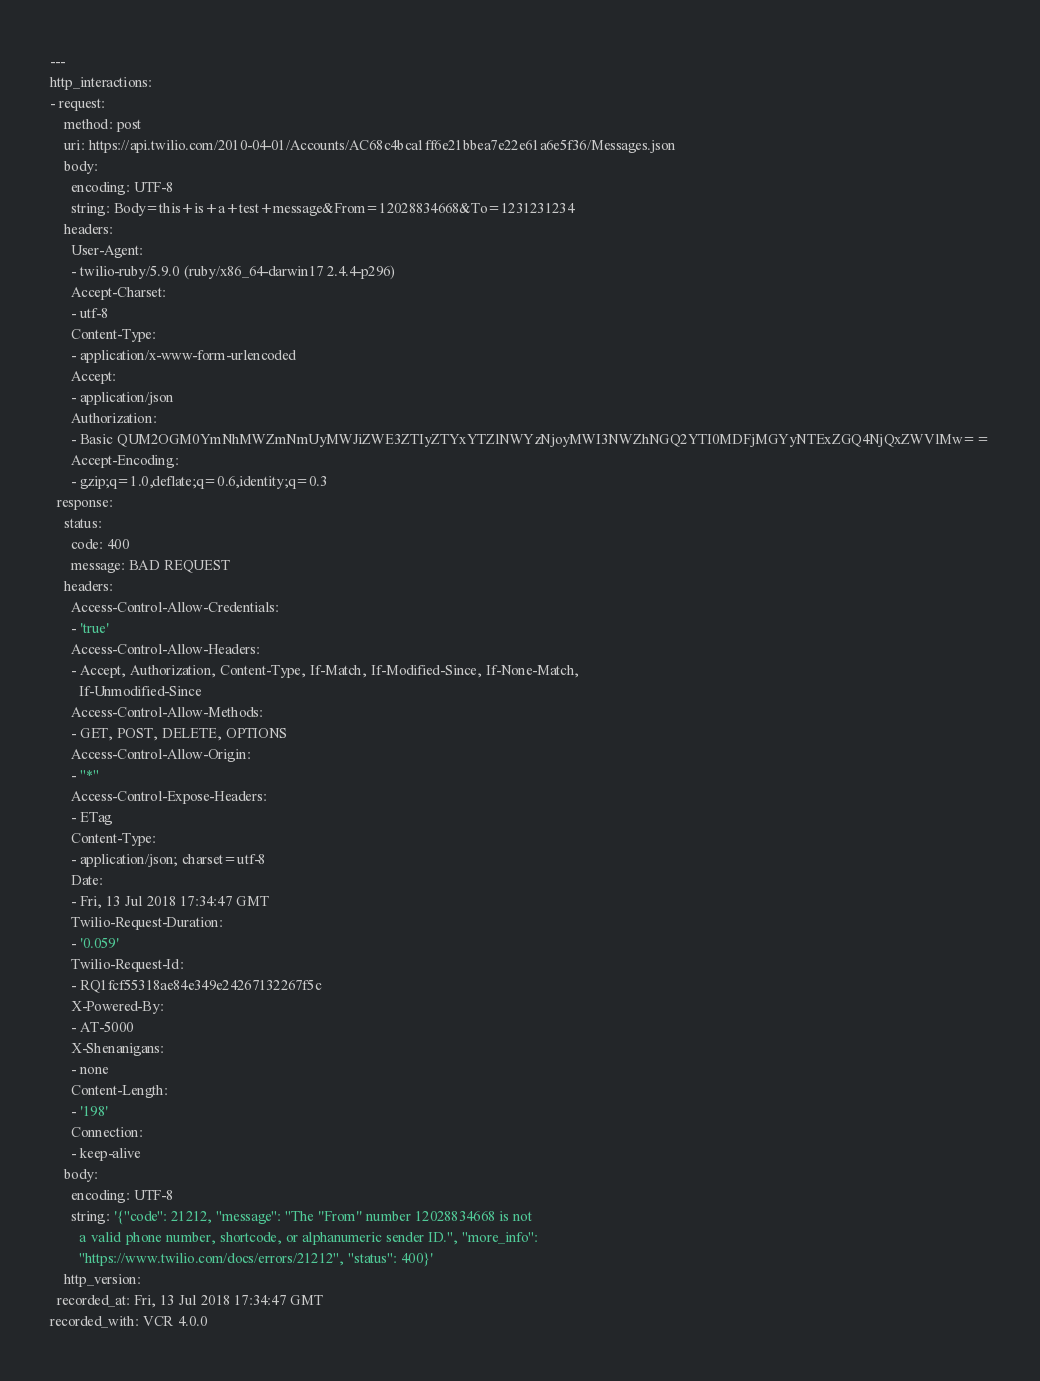<code> <loc_0><loc_0><loc_500><loc_500><_YAML_>---
http_interactions:
- request:
    method: post
    uri: https://api.twilio.com/2010-04-01/Accounts/AC68c4bca1ff6e21bbea7e22e61a6e5f36/Messages.json
    body:
      encoding: UTF-8
      string: Body=this+is+a+test+message&From=12028834668&To=1231231234
    headers:
      User-Agent:
      - twilio-ruby/5.9.0 (ruby/x86_64-darwin17 2.4.4-p296)
      Accept-Charset:
      - utf-8
      Content-Type:
      - application/x-www-form-urlencoded
      Accept:
      - application/json
      Authorization:
      - Basic QUM2OGM0YmNhMWZmNmUyMWJiZWE3ZTIyZTYxYTZlNWYzNjoyMWI3NWZhNGQ2YTI0MDFjMGYyNTExZGQ4NjQxZWVlMw==
      Accept-Encoding:
      - gzip;q=1.0,deflate;q=0.6,identity;q=0.3
  response:
    status:
      code: 400
      message: BAD REQUEST
    headers:
      Access-Control-Allow-Credentials:
      - 'true'
      Access-Control-Allow-Headers:
      - Accept, Authorization, Content-Type, If-Match, If-Modified-Since, If-None-Match,
        If-Unmodified-Since
      Access-Control-Allow-Methods:
      - GET, POST, DELETE, OPTIONS
      Access-Control-Allow-Origin:
      - "*"
      Access-Control-Expose-Headers:
      - ETag
      Content-Type:
      - application/json; charset=utf-8
      Date:
      - Fri, 13 Jul 2018 17:34:47 GMT
      Twilio-Request-Duration:
      - '0.059'
      Twilio-Request-Id:
      - RQ1fcf55318ae84e349e24267132267f5c
      X-Powered-By:
      - AT-5000
      X-Shenanigans:
      - none
      Content-Length:
      - '198'
      Connection:
      - keep-alive
    body:
      encoding: UTF-8
      string: '{"code": 21212, "message": "The ''From'' number 12028834668 is not
        a valid phone number, shortcode, or alphanumeric sender ID.", "more_info":
        "https://www.twilio.com/docs/errors/21212", "status": 400}'
    http_version: 
  recorded_at: Fri, 13 Jul 2018 17:34:47 GMT
recorded_with: VCR 4.0.0
</code> 